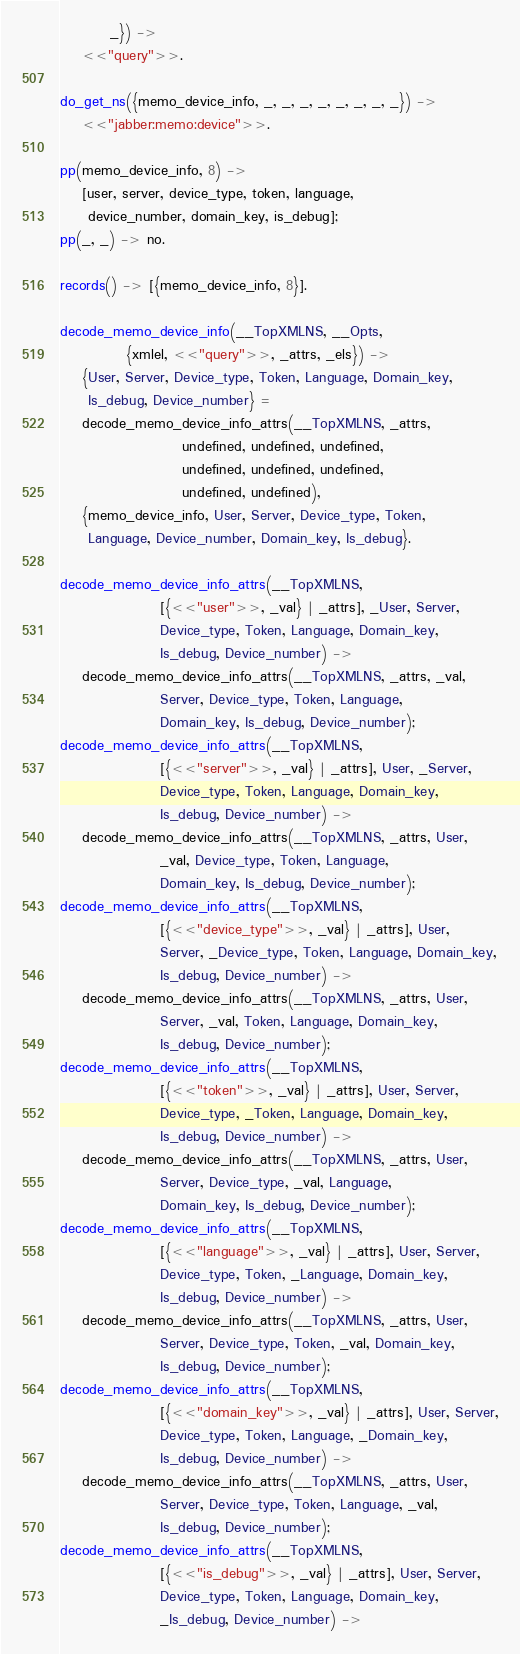Convert code to text. <code><loc_0><loc_0><loc_500><loc_500><_Erlang_>	     _}) ->
    <<"query">>.

do_get_ns({memo_device_info, _, _, _, _, _, _, _, _}) ->
    <<"jabber:memo:device">>.

pp(memo_device_info, 8) ->
    [user, server, device_type, token, language,
     device_number, domain_key, is_debug];
pp(_, _) -> no.

records() -> [{memo_device_info, 8}].

decode_memo_device_info(__TopXMLNS, __Opts,
			{xmlel, <<"query">>, _attrs, _els}) ->
    {User, Server, Device_type, Token, Language, Domain_key,
     Is_debug, Device_number} =
	decode_memo_device_info_attrs(__TopXMLNS, _attrs,
				      undefined, undefined, undefined,
				      undefined, undefined, undefined,
				      undefined, undefined),
    {memo_device_info, User, Server, Device_type, Token,
     Language, Device_number, Domain_key, Is_debug}.

decode_memo_device_info_attrs(__TopXMLNS,
			      [{<<"user">>, _val} | _attrs], _User, Server,
			      Device_type, Token, Language, Domain_key,
			      Is_debug, Device_number) ->
    decode_memo_device_info_attrs(__TopXMLNS, _attrs, _val,
				  Server, Device_type, Token, Language,
				  Domain_key, Is_debug, Device_number);
decode_memo_device_info_attrs(__TopXMLNS,
			      [{<<"server">>, _val} | _attrs], User, _Server,
			      Device_type, Token, Language, Domain_key,
			      Is_debug, Device_number) ->
    decode_memo_device_info_attrs(__TopXMLNS, _attrs, User,
				  _val, Device_type, Token, Language,
				  Domain_key, Is_debug, Device_number);
decode_memo_device_info_attrs(__TopXMLNS,
			      [{<<"device_type">>, _val} | _attrs], User,
			      Server, _Device_type, Token, Language, Domain_key,
			      Is_debug, Device_number) ->
    decode_memo_device_info_attrs(__TopXMLNS, _attrs, User,
				  Server, _val, Token, Language, Domain_key,
				  Is_debug, Device_number);
decode_memo_device_info_attrs(__TopXMLNS,
			      [{<<"token">>, _val} | _attrs], User, Server,
			      Device_type, _Token, Language, Domain_key,
			      Is_debug, Device_number) ->
    decode_memo_device_info_attrs(__TopXMLNS, _attrs, User,
				  Server, Device_type, _val, Language,
				  Domain_key, Is_debug, Device_number);
decode_memo_device_info_attrs(__TopXMLNS,
			      [{<<"language">>, _val} | _attrs], User, Server,
			      Device_type, Token, _Language, Domain_key,
			      Is_debug, Device_number) ->
    decode_memo_device_info_attrs(__TopXMLNS, _attrs, User,
				  Server, Device_type, Token, _val, Domain_key,
				  Is_debug, Device_number);
decode_memo_device_info_attrs(__TopXMLNS,
			      [{<<"domain_key">>, _val} | _attrs], User, Server,
			      Device_type, Token, Language, _Domain_key,
			      Is_debug, Device_number) ->
    decode_memo_device_info_attrs(__TopXMLNS, _attrs, User,
				  Server, Device_type, Token, Language, _val,
				  Is_debug, Device_number);
decode_memo_device_info_attrs(__TopXMLNS,
			      [{<<"is_debug">>, _val} | _attrs], User, Server,
			      Device_type, Token, Language, Domain_key,
			      _Is_debug, Device_number) -></code> 